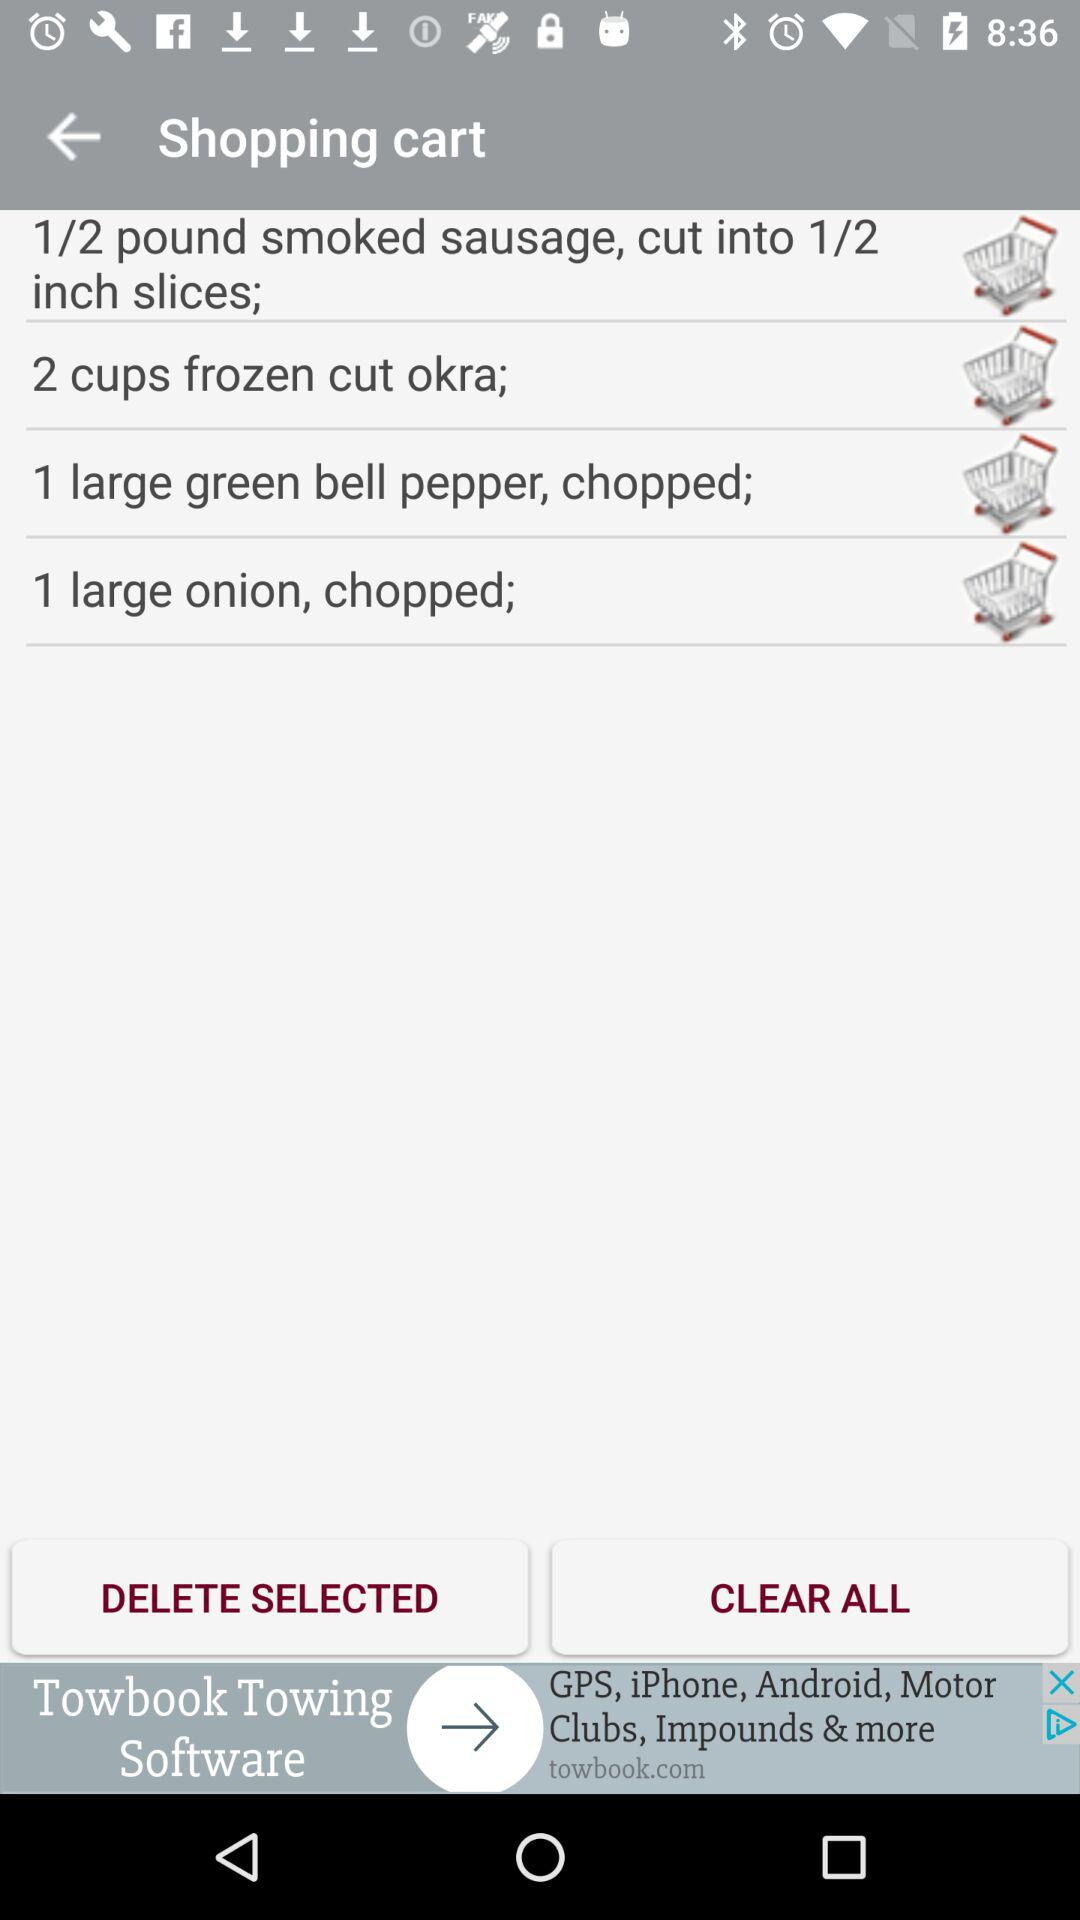How many items are in the cart?
Answer the question using a single word or phrase. 4 